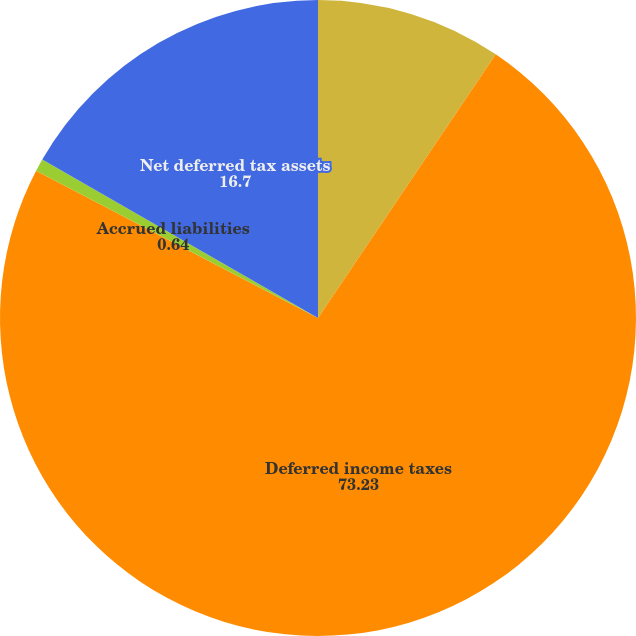Convert chart. <chart><loc_0><loc_0><loc_500><loc_500><pie_chart><fcel>Other current assets<fcel>Deferred income taxes<fcel>Accrued liabilities<fcel>Net deferred tax assets<nl><fcel>9.44%<fcel>73.23%<fcel>0.64%<fcel>16.7%<nl></chart> 